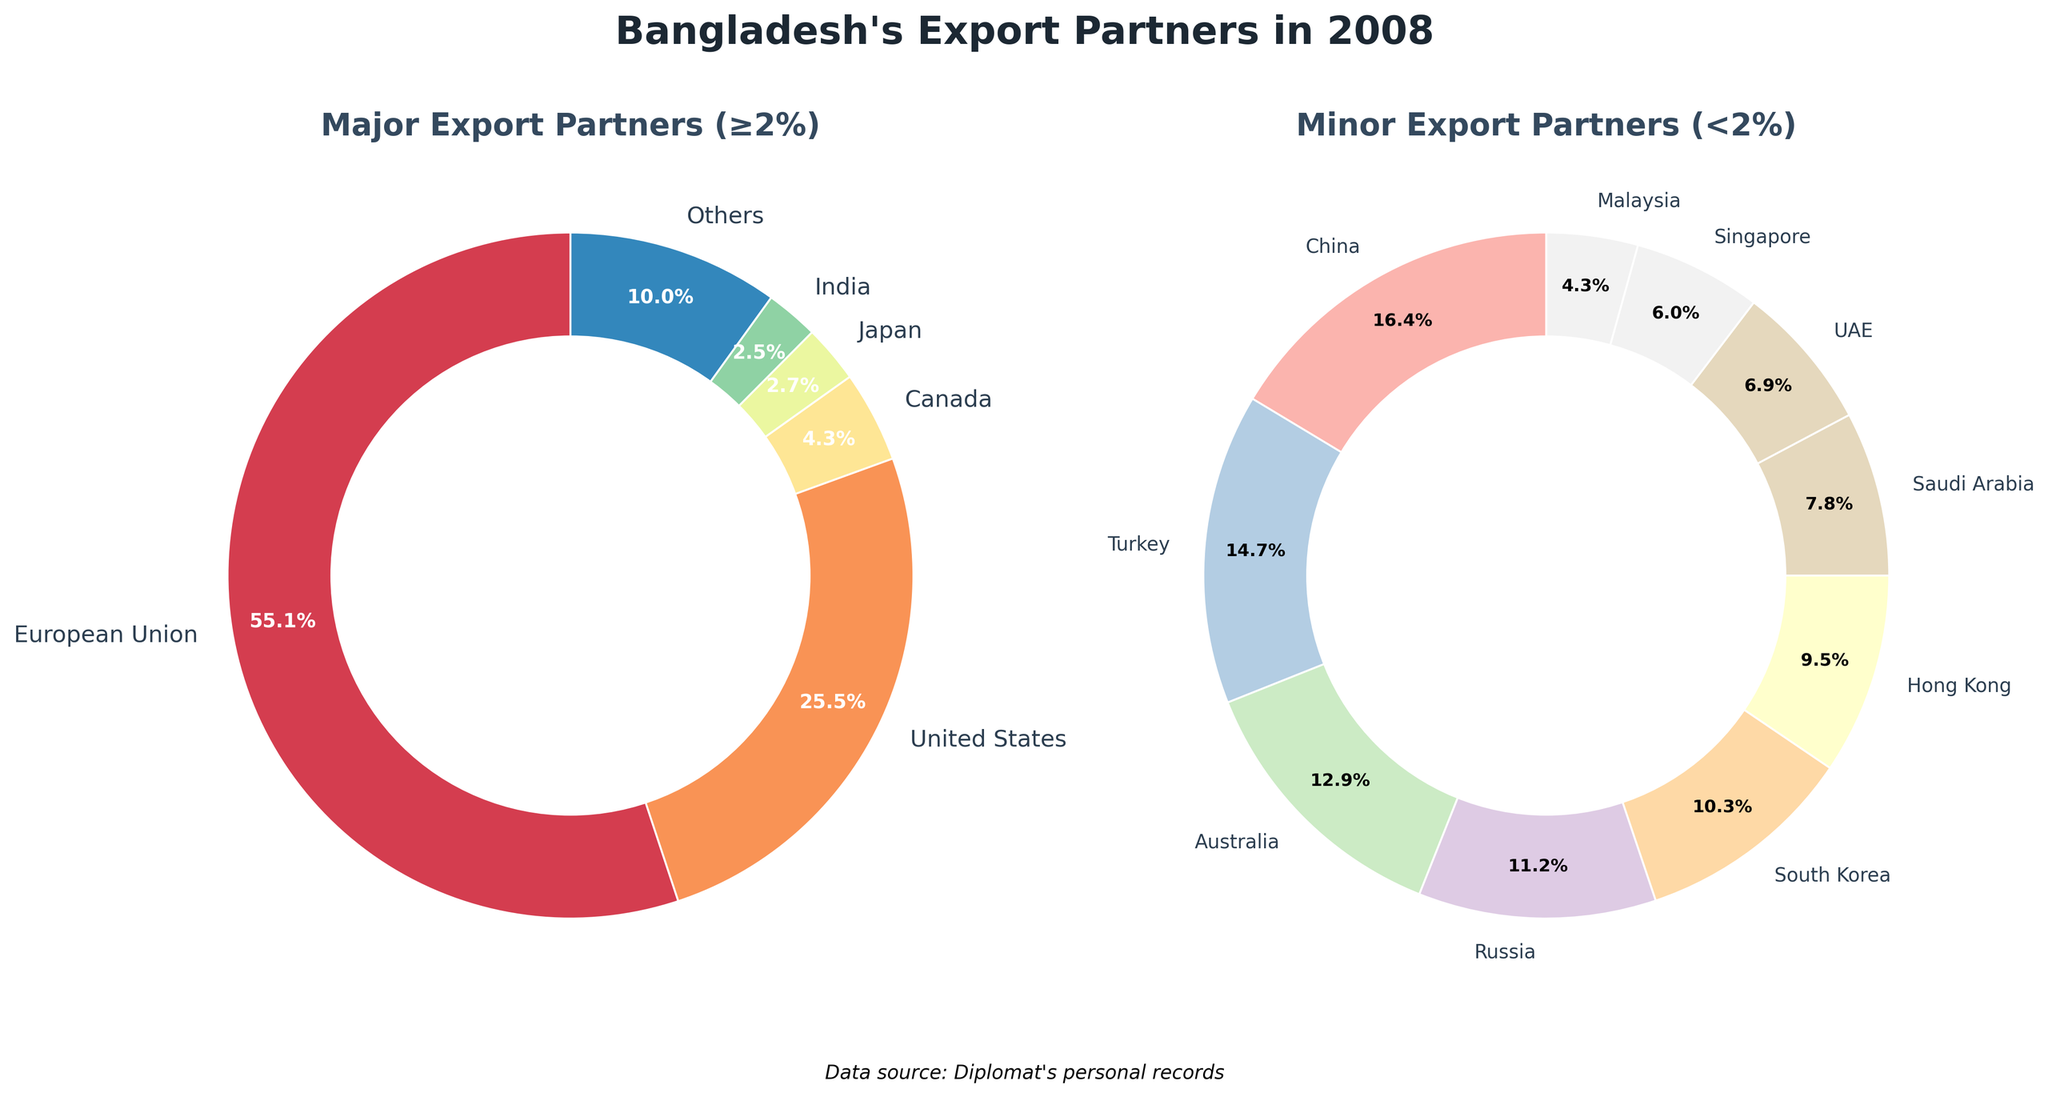What percentage of Bangladesh's exports in 2008 went to the European Union? From the pie chart titled 'Major Export Partners (≥2%)', look for the label 'European Union' and note its percentage value.
Answer: 48.7% What is the combined percentage of Bangladesh's exports to the United States and Canada in 2008? From the pie chart titled 'Major Export Partners (≥2%)', locate the percentages for 'United States' (22.5%) and 'Canada' (3.8%), then add them together: 22.5% + 3.8% = 26.3%.
Answer: 26.3% Which country received the lowest percentage of Bangladesh's exports among the minor export partners (<2%)? From the pie chart titled 'Minor Export Partners (<2%)', identify the country with the smallest wedge. 'Malaysia' has the smallest percentage (0.5%).
Answer: Malaysia What is the total percentage of exports to the countries labeled as 'Others'? From the data, the percentage for 'Others' is directly listed as 8.8%.
Answer: 8.8% Which country, between Russia and South Korea, has a higher percentage of Bangladesh's exports in 2008? Compare the wedges labeled 'Russia' (1.3%) and 'South Korea' (1.2%) in the 'Minor Export Partners (<2%)' chart. Russia has a higher percentage.
Answer: Russia How much more does the European Union receive in exports compared to Japan? Find the percentages for 'European Union' (48.7%) and 'Japan' (2.4%) from the 'Major Export Partners (≥2%)' chart and subtract: 48.7% - 2.4% = 46.3%.
Answer: 46.3% What is the average export percentage to China, Turkey, Australia, Russia, and South Korea? Sum the percentages of these countries: 1.9% (China) + 1.7% (Turkey) + 1.5% (Australia) + 1.3% (Russia) + 1.2% (South Korea) = 7.6%. Then divide by the number of countries: 7.6% / 5 = 1.52%.
Answer: 1.52% Identify the country that receives the second-largest percentage of Bangladesh's exports. From the 'Major Export Partners (≥2%)' chart, after the European Union (48.7%), the next largest segment is for the United States (22.5%).
Answer: United States What is the difference in export percentages between India and the UAE? From the data, subtract the UAE percentage (0.8%) from India (2.2%): 2.2% - 0.8% = 1.4%.
Answer: 1.4% What percentage of Bangladesh's exports in 2008 went to countries other than the United States and the European Union? To find this, first sum the percentages of the United States (22.5%) and European Union (48.7%): 22.5% + 48.7% = 71.2%. Then subtract this from 100%: 100% - 71.2% = 28.8%.
Answer: 28.8% 